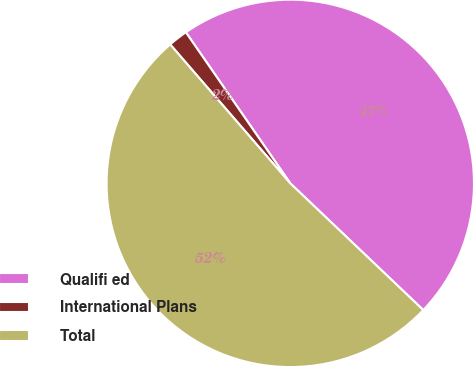<chart> <loc_0><loc_0><loc_500><loc_500><pie_chart><fcel>Qualifi ed<fcel>International Plans<fcel>Total<nl><fcel>46.74%<fcel>1.72%<fcel>51.54%<nl></chart> 